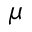Convert formula to latex. <formula><loc_0><loc_0><loc_500><loc_500>\mu</formula> 